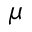Convert formula to latex. <formula><loc_0><loc_0><loc_500><loc_500>\mu</formula> 